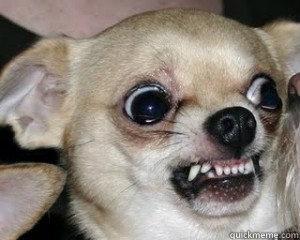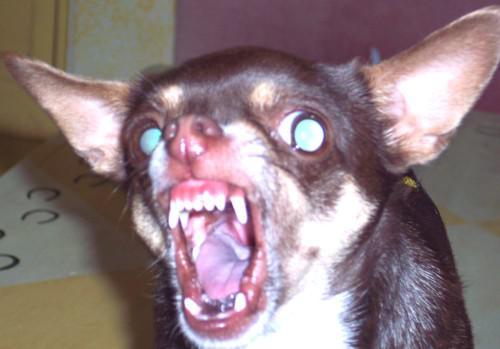The first image is the image on the left, the second image is the image on the right. Considering the images on both sides, is "The dog in the image on the left is baring its teeth." valid? Answer yes or no. Yes. The first image is the image on the left, the second image is the image on the right. Analyze the images presented: Is the assertion "There is only one dog baring its teeth, in total." valid? Answer yes or no. No. 